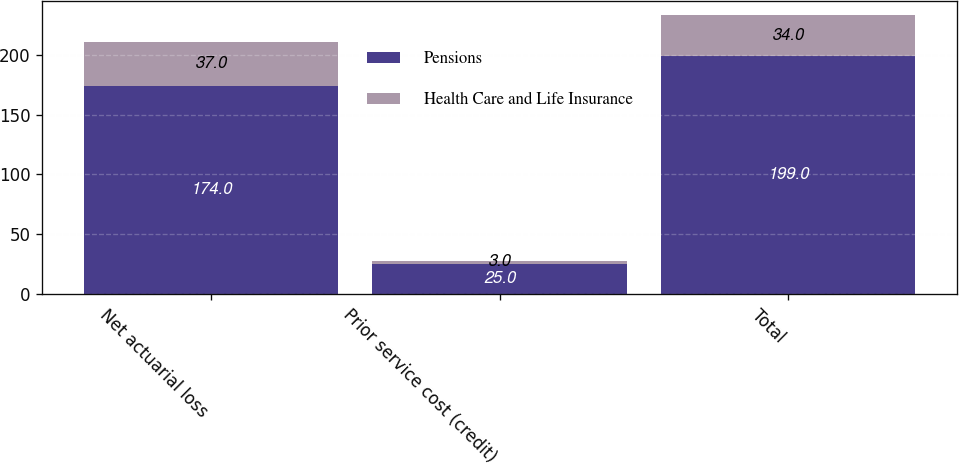Convert chart. <chart><loc_0><loc_0><loc_500><loc_500><stacked_bar_chart><ecel><fcel>Net actuarial loss<fcel>Prior service cost (credit)<fcel>Total<nl><fcel>Pensions<fcel>174<fcel>25<fcel>199<nl><fcel>Health Care and Life Insurance<fcel>37<fcel>3<fcel>34<nl></chart> 